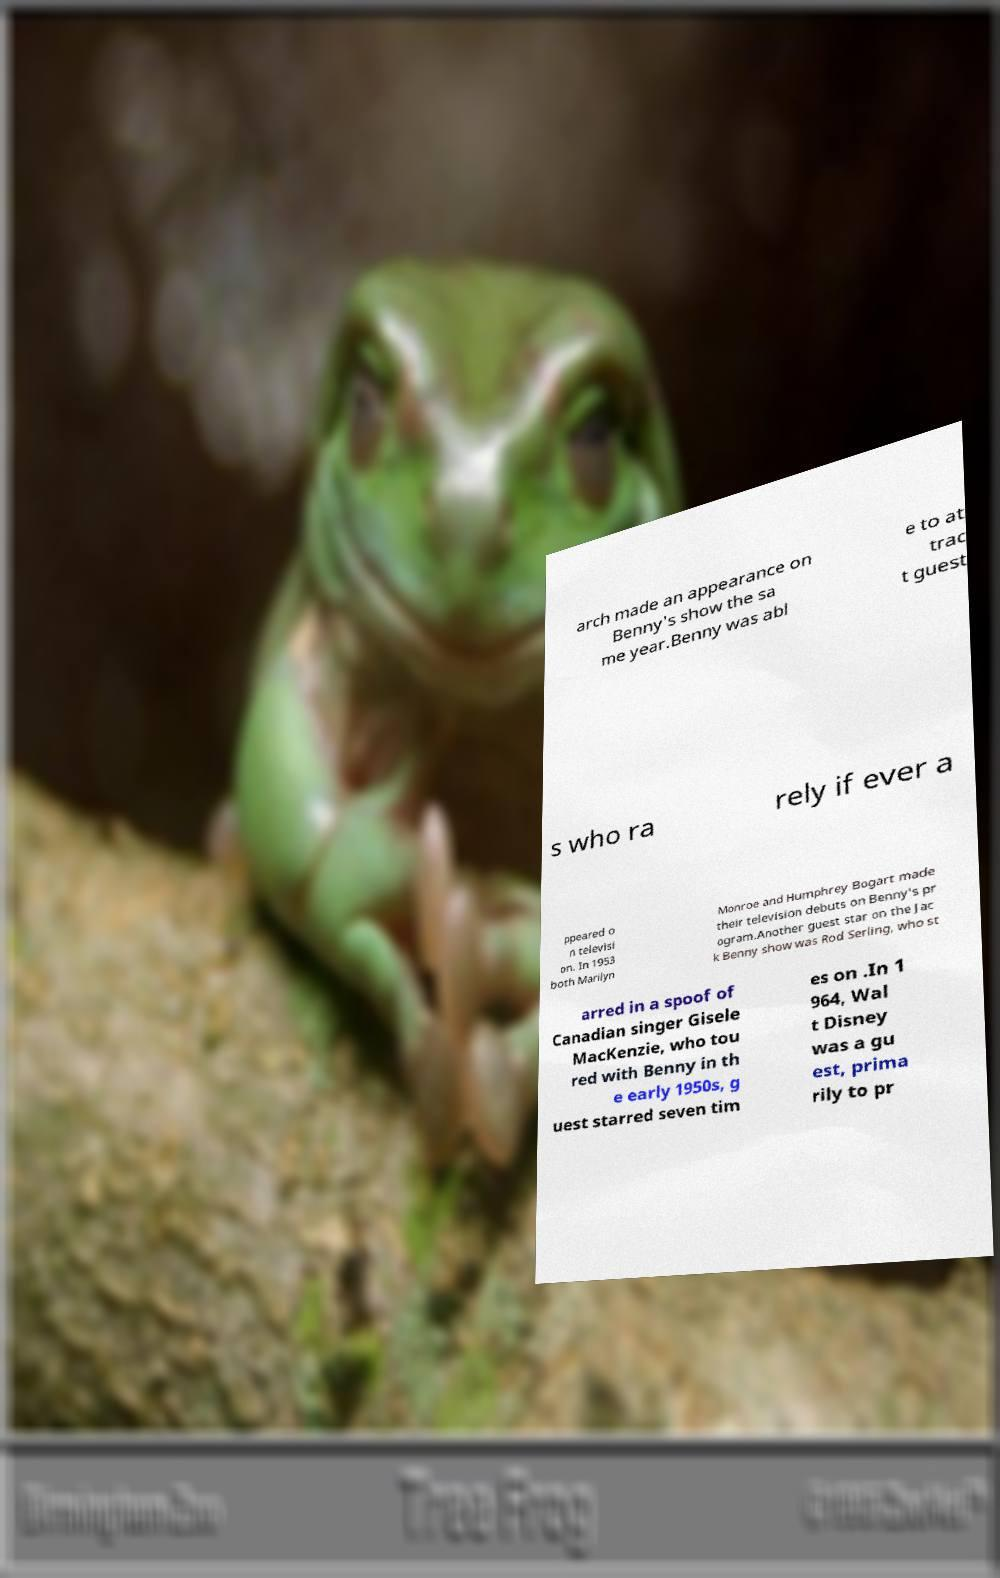What messages or text are displayed in this image? I need them in a readable, typed format. arch made an appearance on Benny's show the sa me year.Benny was abl e to at trac t guest s who ra rely if ever a ppeared o n televisi on. In 1953 both Marilyn Monroe and Humphrey Bogart made their television debuts on Benny's pr ogram.Another guest star on the Jac k Benny show was Rod Serling, who st arred in a spoof of Canadian singer Gisele MacKenzie, who tou red with Benny in th e early 1950s, g uest starred seven tim es on .In 1 964, Wal t Disney was a gu est, prima rily to pr 